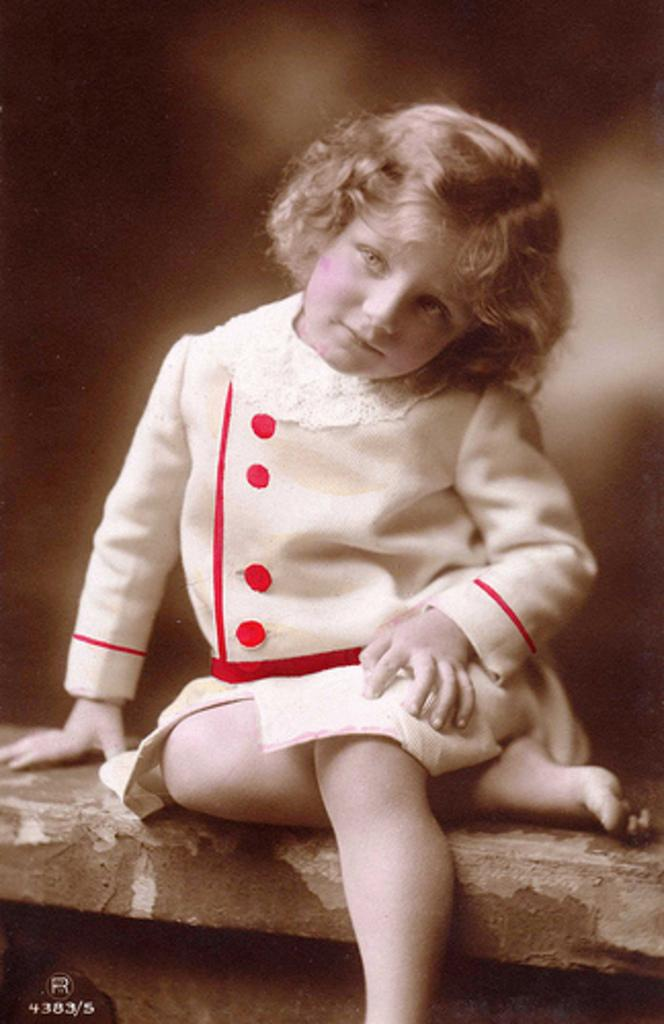What is the person in the image doing? The person is sitting in the image. What is the person wearing? The person is wearing a red and white color dress. Can you describe the background of the image? The background of the image is blurred. What type of liquid can be seen on the desk in the image? There is no desk present in the image, and therefore no liquid can be seen on it. 